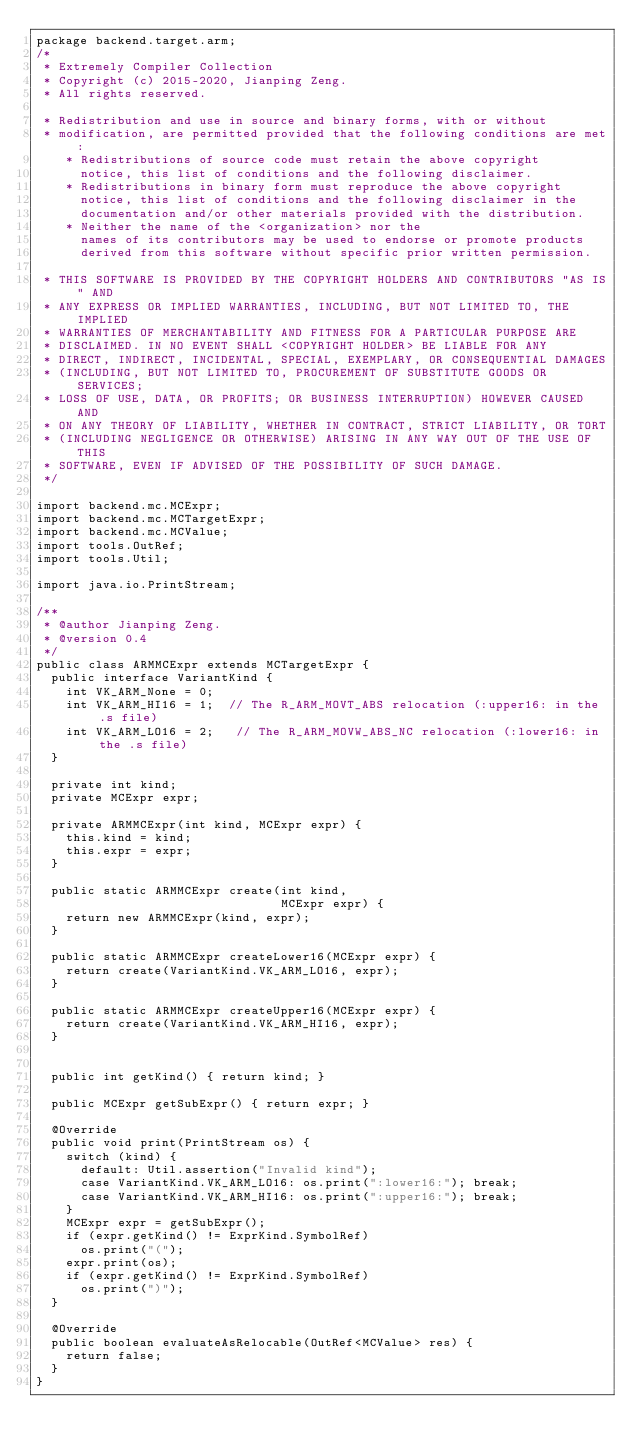<code> <loc_0><loc_0><loc_500><loc_500><_Java_>package backend.target.arm;
/*
 * Extremely Compiler Collection
 * Copyright (c) 2015-2020, Jianping Zeng.
 * All rights reserved.
 
 * Redistribution and use in source and binary forms, with or without
 * modification, are permitted provided that the following conditions are met:
    * Redistributions of source code must retain the above copyright
      notice, this list of conditions and the following disclaimer.
    * Redistributions in binary form must reproduce the above copyright
      notice, this list of conditions and the following disclaimer in the
      documentation and/or other materials provided with the distribution.
    * Neither the name of the <organization> nor the
      names of its contributors may be used to endorse or promote products
      derived from this software without specific prior written permission.

 * THIS SOFTWARE IS PROVIDED BY THE COPYRIGHT HOLDERS AND CONTRIBUTORS "AS IS" AND
 * ANY EXPRESS OR IMPLIED WARRANTIES, INCLUDING, BUT NOT LIMITED TO, THE IMPLIED
 * WARRANTIES OF MERCHANTABILITY AND FITNESS FOR A PARTICULAR PURPOSE ARE
 * DISCLAIMED. IN NO EVENT SHALL <COPYRIGHT HOLDER> BE LIABLE FOR ANY
 * DIRECT, INDIRECT, INCIDENTAL, SPECIAL, EXEMPLARY, OR CONSEQUENTIAL DAMAGES
 * (INCLUDING, BUT NOT LIMITED TO, PROCUREMENT OF SUBSTITUTE GOODS OR SERVICES;
 * LOSS OF USE, DATA, OR PROFITS; OR BUSINESS INTERRUPTION) HOWEVER CAUSED AND
 * ON ANY THEORY OF LIABILITY, WHETHER IN CONTRACT, STRICT LIABILITY, OR TORT
 * (INCLUDING NEGLIGENCE OR OTHERWISE) ARISING IN ANY WAY OUT OF THE USE OF THIS
 * SOFTWARE, EVEN IF ADVISED OF THE POSSIBILITY OF SUCH DAMAGE.
 */

import backend.mc.MCExpr;
import backend.mc.MCTargetExpr;
import backend.mc.MCValue;
import tools.OutRef;
import tools.Util;

import java.io.PrintStream;

/**
 * @author Jianping Zeng.
 * @version 0.4
 */
public class ARMMCExpr extends MCTargetExpr {
  public interface VariantKind {
    int VK_ARM_None = 0;
    int VK_ARM_HI16 = 1;  // The R_ARM_MOVT_ABS relocation (:upper16: in the .s file)
    int VK_ARM_LO16 = 2;   // The R_ARM_MOVW_ABS_NC relocation (:lower16: in the .s file)
  }

  private int kind;
  private MCExpr expr;

  private ARMMCExpr(int kind, MCExpr expr) {
    this.kind = kind;
    this.expr = expr;
  }

  public static ARMMCExpr create(int kind,
                                 MCExpr expr) {
    return new ARMMCExpr(kind, expr);
  }

  public static ARMMCExpr createLower16(MCExpr expr) {
    return create(VariantKind.VK_ARM_LO16, expr);
  }

  public static ARMMCExpr createUpper16(MCExpr expr) {
    return create(VariantKind.VK_ARM_HI16, expr);
  }


  public int getKind() { return kind; }

  public MCExpr getSubExpr() { return expr; }

  @Override
  public void print(PrintStream os) {
    switch (kind) {
      default: Util.assertion("Invalid kind");
      case VariantKind.VK_ARM_LO16: os.print(":lower16:"); break;
      case VariantKind.VK_ARM_HI16: os.print(":upper16:"); break;
    }
    MCExpr expr = getSubExpr();
    if (expr.getKind() != ExprKind.SymbolRef)
      os.print("(");
    expr.print(os);
    if (expr.getKind() != ExprKind.SymbolRef)
      os.print(")");
  }

  @Override
  public boolean evaluateAsRelocable(OutRef<MCValue> res) {
    return false;
  }
}
</code> 